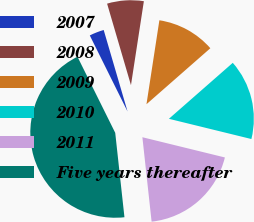<chart> <loc_0><loc_0><loc_500><loc_500><pie_chart><fcel>2007<fcel>2008<fcel>2009<fcel>2010<fcel>2011<fcel>Five years thereafter<nl><fcel>2.8%<fcel>6.96%<fcel>11.12%<fcel>15.28%<fcel>19.44%<fcel>44.4%<nl></chart> 